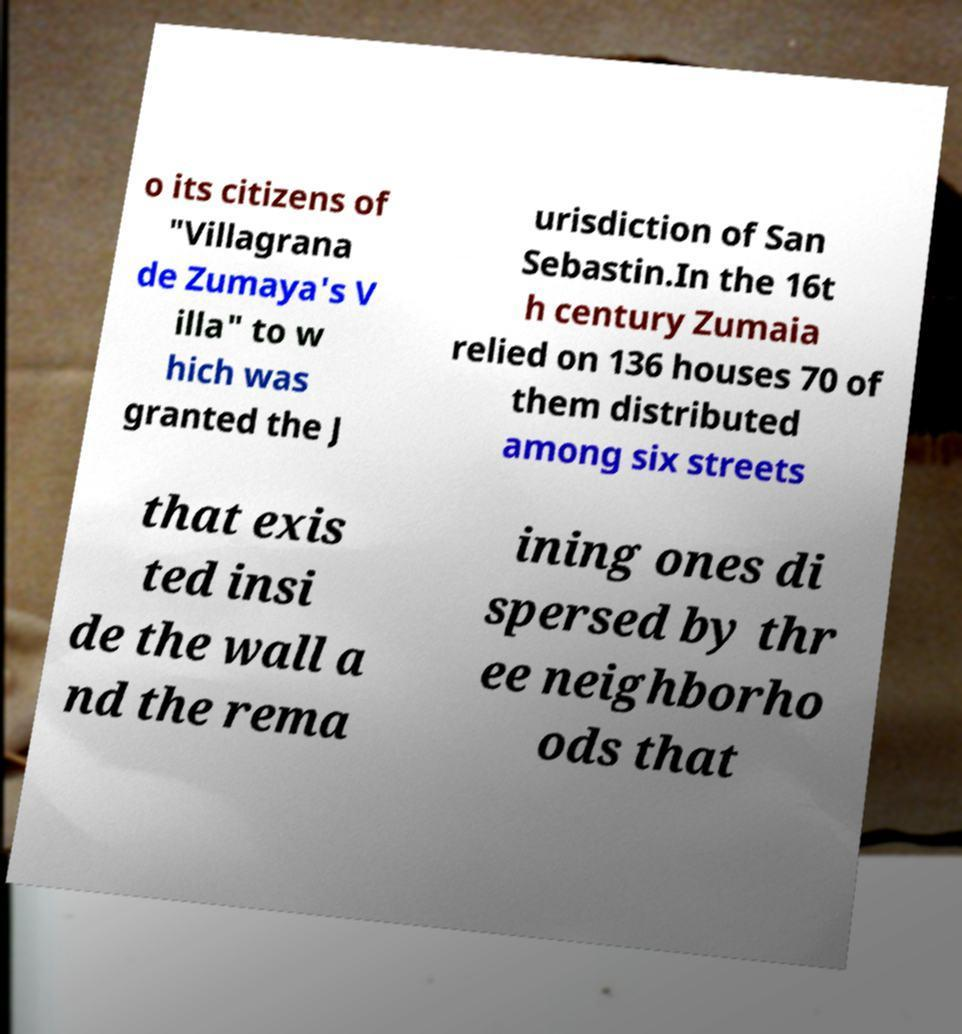Please read and relay the text visible in this image. What does it say? o its citizens of "Villagrana de Zumaya's V illa" to w hich was granted the J urisdiction of San Sebastin.In the 16t h century Zumaia relied on 136 houses 70 of them distributed among six streets that exis ted insi de the wall a nd the rema ining ones di spersed by thr ee neighborho ods that 